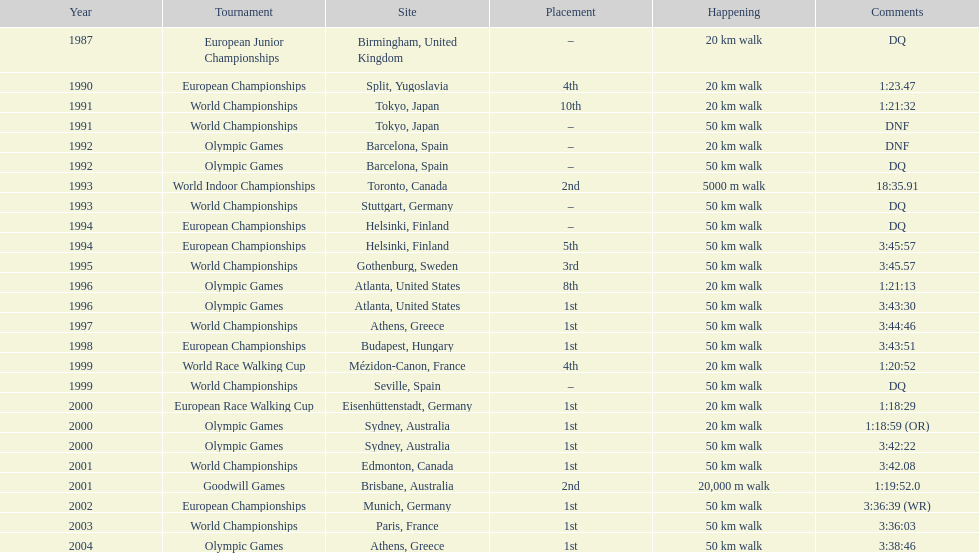How long did it take to walk 50 km in the 2004 olympic games? 3:38:46. 